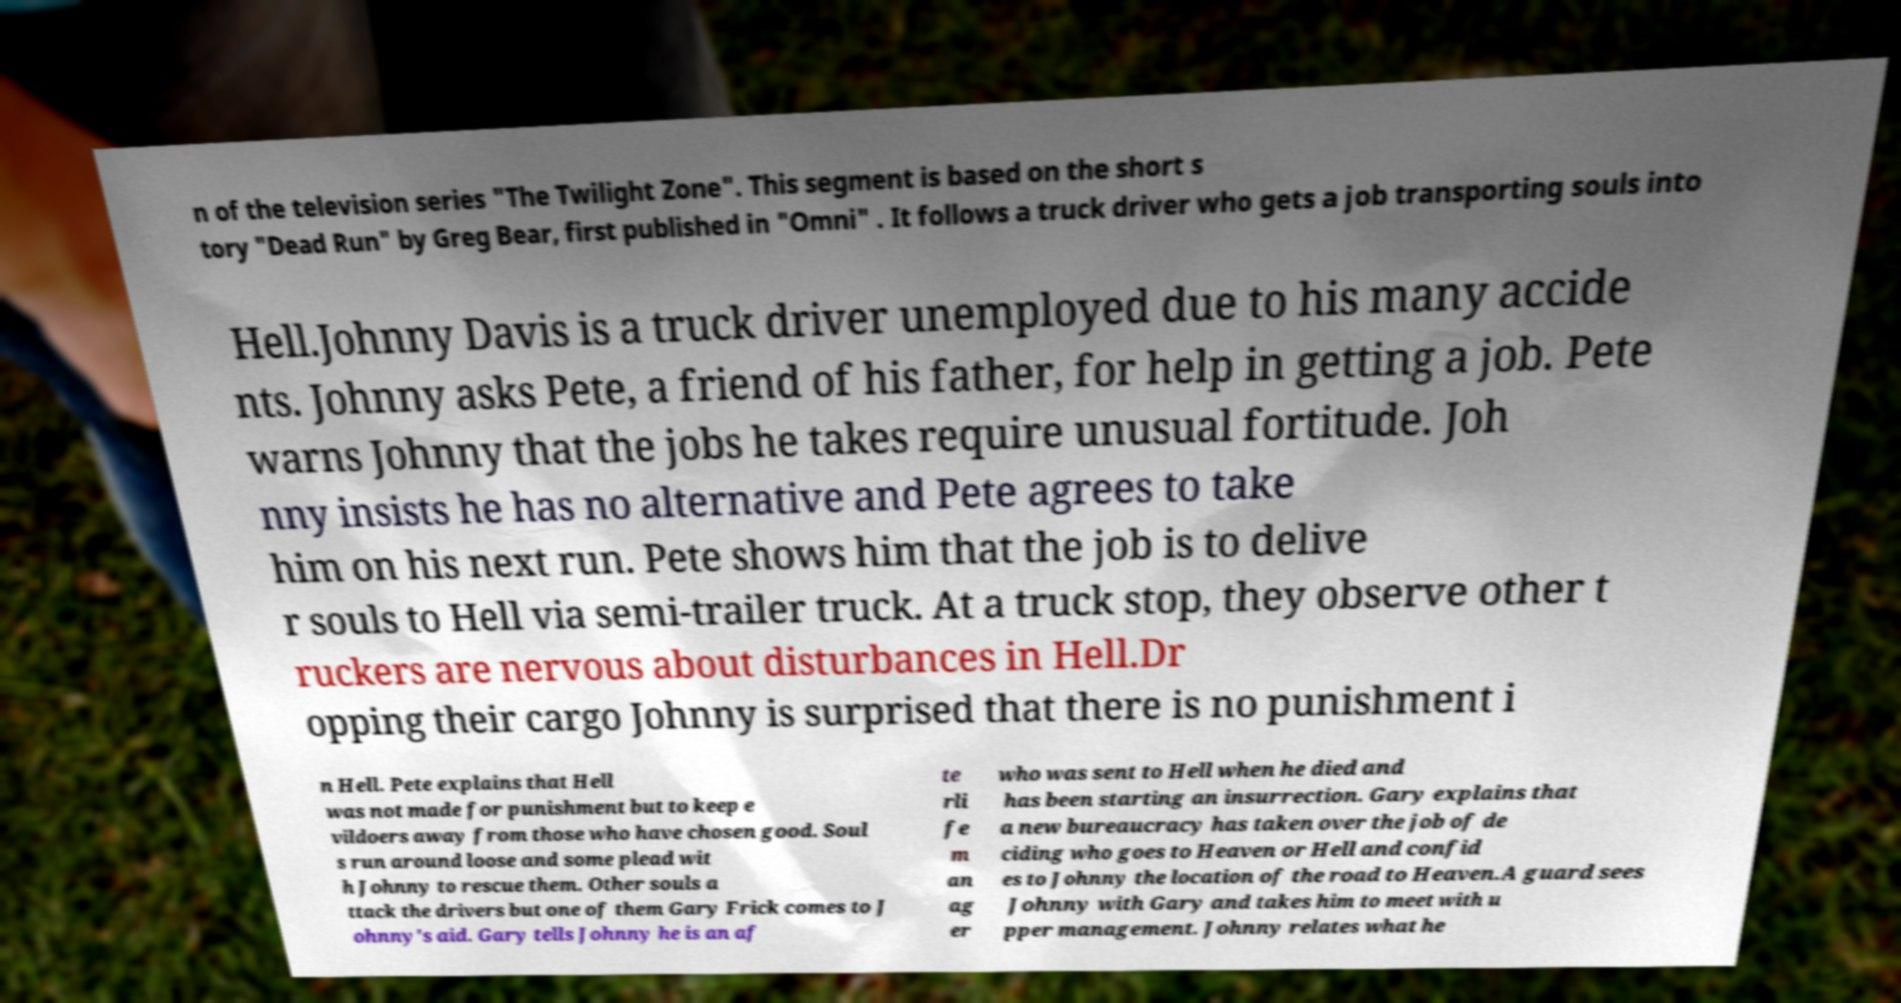I need the written content from this picture converted into text. Can you do that? n of the television series "The Twilight Zone". This segment is based on the short s tory "Dead Run" by Greg Bear, first published in "Omni" . It follows a truck driver who gets a job transporting souls into Hell.Johnny Davis is a truck driver unemployed due to his many accide nts. Johnny asks Pete, a friend of his father, for help in getting a job. Pete warns Johnny that the jobs he takes require unusual fortitude. Joh nny insists he has no alternative and Pete agrees to take him on his next run. Pete shows him that the job is to delive r souls to Hell via semi-trailer truck. At a truck stop, they observe other t ruckers are nervous about disturbances in Hell.Dr opping their cargo Johnny is surprised that there is no punishment i n Hell. Pete explains that Hell was not made for punishment but to keep e vildoers away from those who have chosen good. Soul s run around loose and some plead wit h Johnny to rescue them. Other souls a ttack the drivers but one of them Gary Frick comes to J ohnny's aid. Gary tells Johnny he is an af te rli fe m an ag er who was sent to Hell when he died and has been starting an insurrection. Gary explains that a new bureaucracy has taken over the job of de ciding who goes to Heaven or Hell and confid es to Johnny the location of the road to Heaven.A guard sees Johnny with Gary and takes him to meet with u pper management. Johnny relates what he 